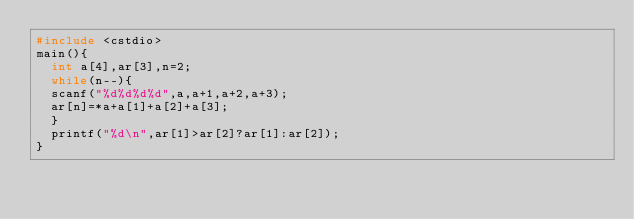<code> <loc_0><loc_0><loc_500><loc_500><_C++_>#include <cstdio>
main(){
	int a[4],ar[3],n=2;
	while(n--){
	scanf("%d%d%d%d",a,a+1,a+2,a+3);
	ar[n]=*a+a[1]+a[2]+a[3];
	}
	printf("%d\n",ar[1]>ar[2]?ar[1]:ar[2]);
}</code> 